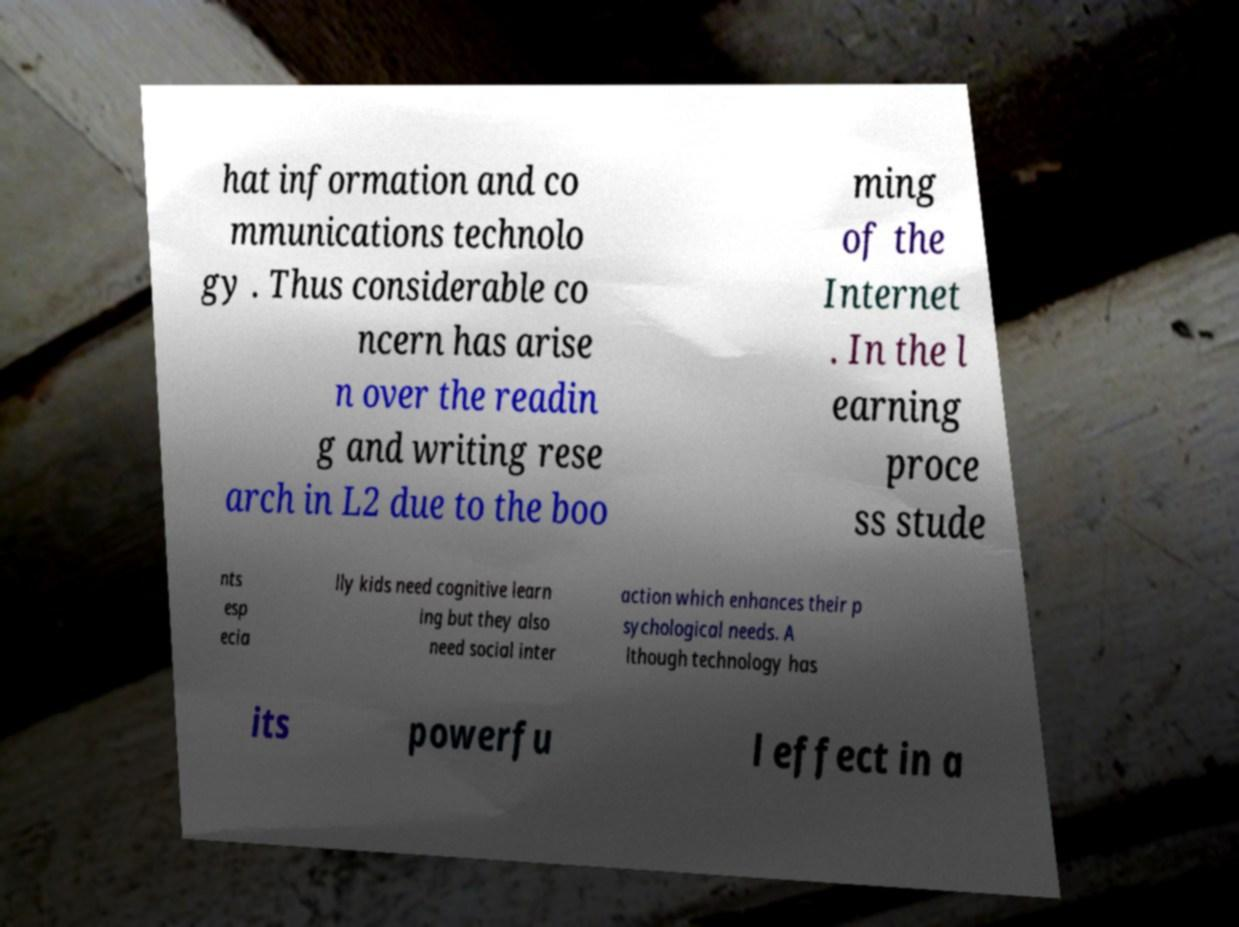What messages or text are displayed in this image? I need them in a readable, typed format. hat information and co mmunications technolo gy . Thus considerable co ncern has arise n over the readin g and writing rese arch in L2 due to the boo ming of the Internet . In the l earning proce ss stude nts esp ecia lly kids need cognitive learn ing but they also need social inter action which enhances their p sychological needs. A lthough technology has its powerfu l effect in a 